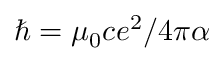<formula> <loc_0><loc_0><loc_500><loc_500>\hbar { = } \mu _ { 0 } c e ^ { 2 } / 4 \pi \alpha</formula> 